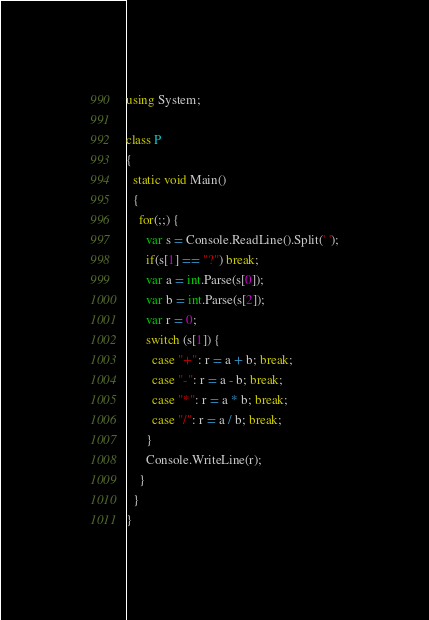<code> <loc_0><loc_0><loc_500><loc_500><_C#_>using System;

class P
{
  static void Main()
  {
    for(;;) {
      var s = Console.ReadLine().Split(' ');
      if(s[1] == "?") break;
      var a = int.Parse(s[0]);
      var b = int.Parse(s[2]);
      var r = 0;
      switch (s[1]) {
        case "+": r = a + b; break;
        case "-": r = a - b; break;
        case "*": r = a * b; break;
        case "/": r = a / b; break;
      }
      Console.WriteLine(r);
    }
  }
}</code> 